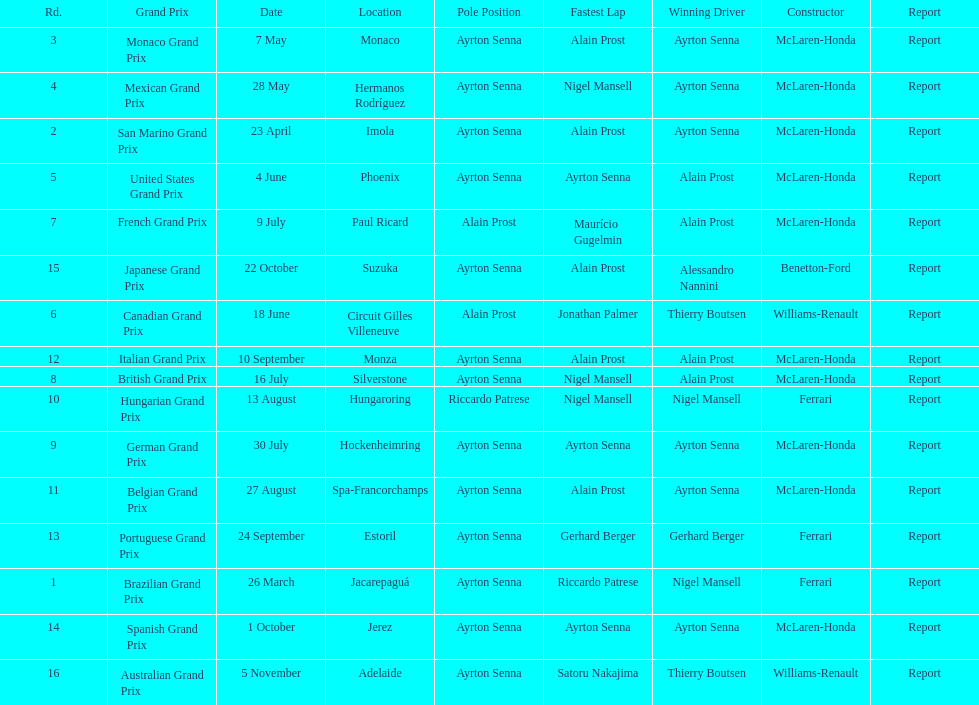How many times was ayrton senna in pole position? 13. 